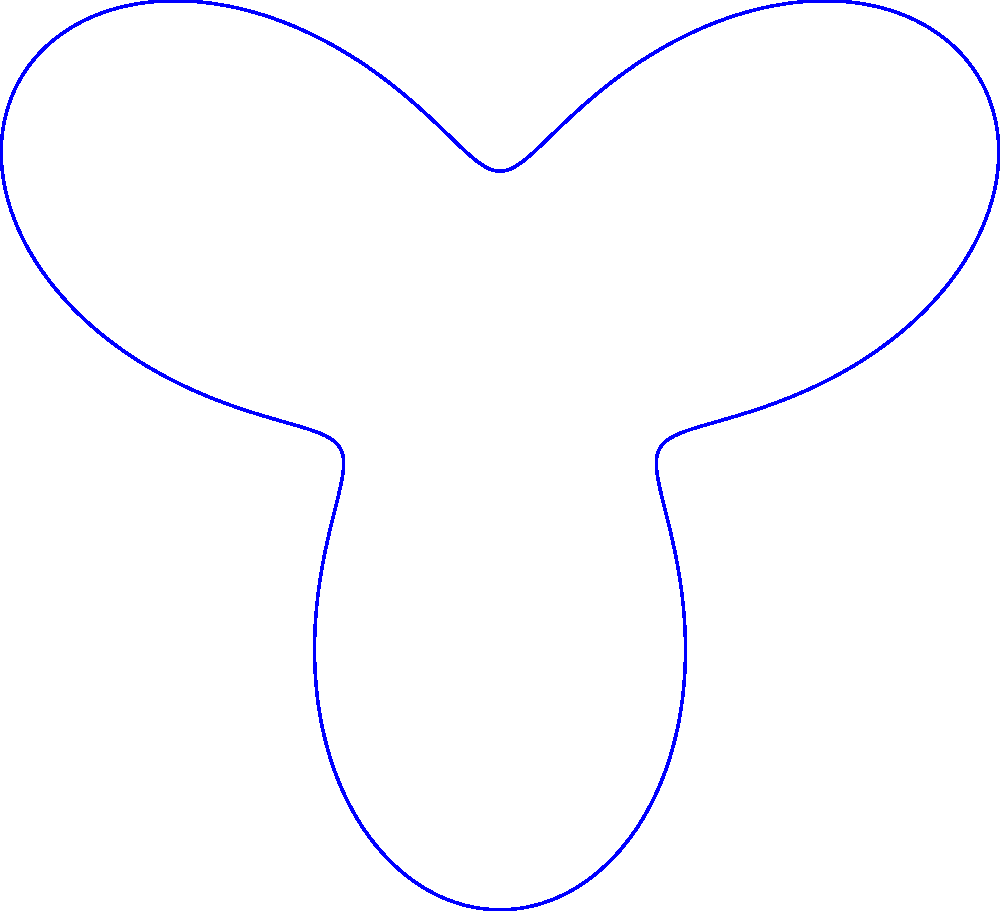In the unconventional coordinate system shown, which is defined by $r(\theta) = 2 + \sin(3\theta)$, how might the distribution of dark matter (represented by red dots) challenge the standard $\Lambda$CDM model of cosmology? Propose a novel interpretation based on this representation. To answer this question, let's analyze the unconventional coordinate system and its implications:

1. The coordinate system is defined by $r(\theta) = 2 + \sin(3\theta)$, creating a "tri-lobed" pattern.

2. This pattern suggests a non-uniform, periodic distribution of space in the galaxy cluster.

3. The dark matter (red dots) appears to be concentrated more heavily in certain regions, particularly near the lobes of the coordinate system.

4. Standard $\Lambda$CDM model assumes a relatively smooth, spherically symmetric distribution of dark matter in galaxy clusters.

5. The pattern observed here suggests a more complex, possibly fractal-like distribution of dark matter.

6. This distribution could imply that dark matter interacts with itself or ordinary matter more strongly than currently believed.

7. The periodic nature of the coordinate system might suggest a wave-like property of dark matter, challenging its assumed particle nature.

8. Such a distribution could be interpreted as evidence for modified gravity theories, where the apparent effects of dark matter are actually due to variations in the strength of gravity.

9. The concentration of dark matter near the lobes could indicate a connection between dark matter and the geometry of space-time itself.

10. This representation might suggest that dark matter is not a uniform, cold medium, but rather a dynamic, possibly even quantum mechanical phenomenon.
Answer: Wave-like dark matter with geometry-dependent distribution, challenging $\Lambda$CDM's smooth, particle-based model. 